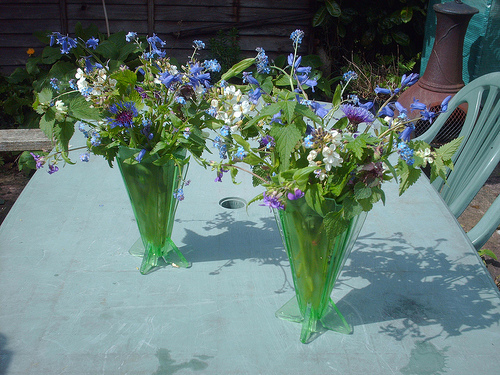Please provide a short description for this region: [0.84, 0.27, 0.97, 0.57]. The area captures a green plastic chair with a slightly reclined back, conveniently placed next to a blue table in an outdoor setting. 